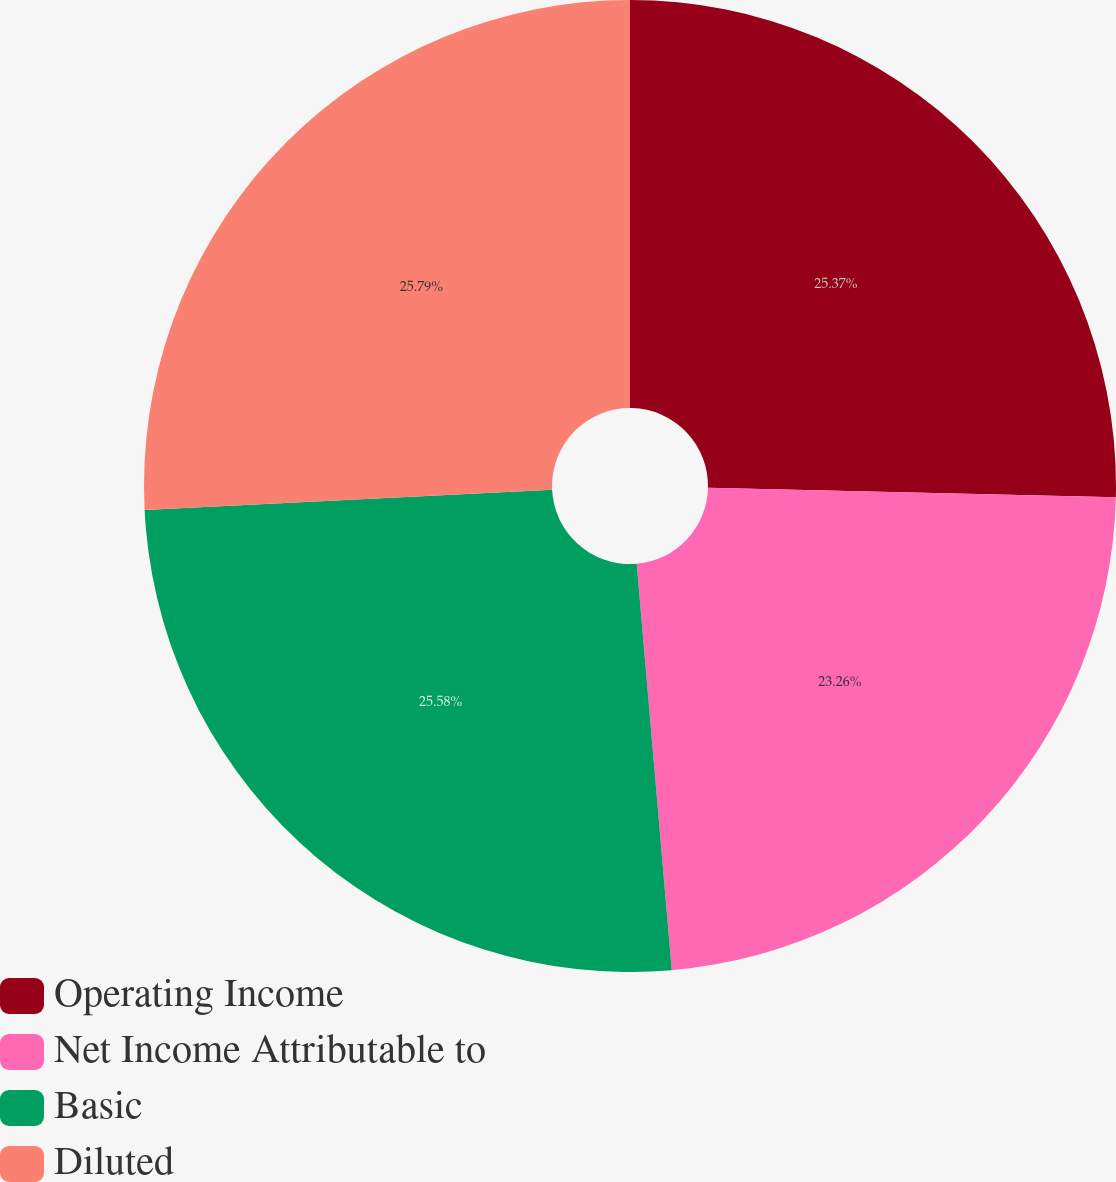Convert chart to OTSL. <chart><loc_0><loc_0><loc_500><loc_500><pie_chart><fcel>Operating Income<fcel>Net Income Attributable to<fcel>Basic<fcel>Diluted<nl><fcel>25.37%<fcel>23.26%<fcel>25.58%<fcel>25.79%<nl></chart> 